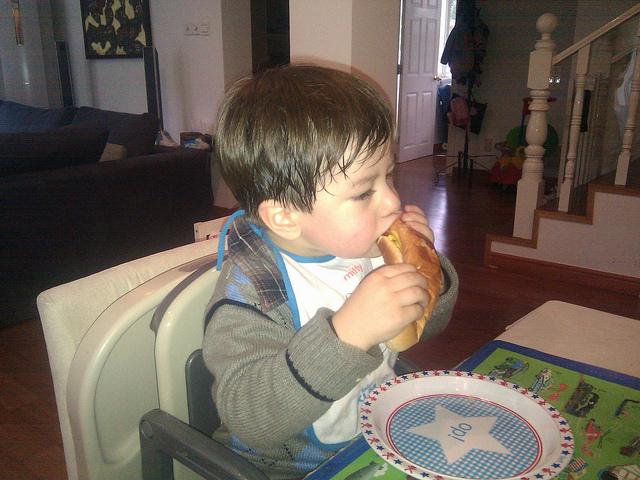What shape is in the center of the plate?
Short answer required. Star. What does this child have around its neck?
Be succinct. Bib. Is the child hungry?
Write a very short answer. Yes. What is the kid eating?
Quick response, please. Hot dog. 